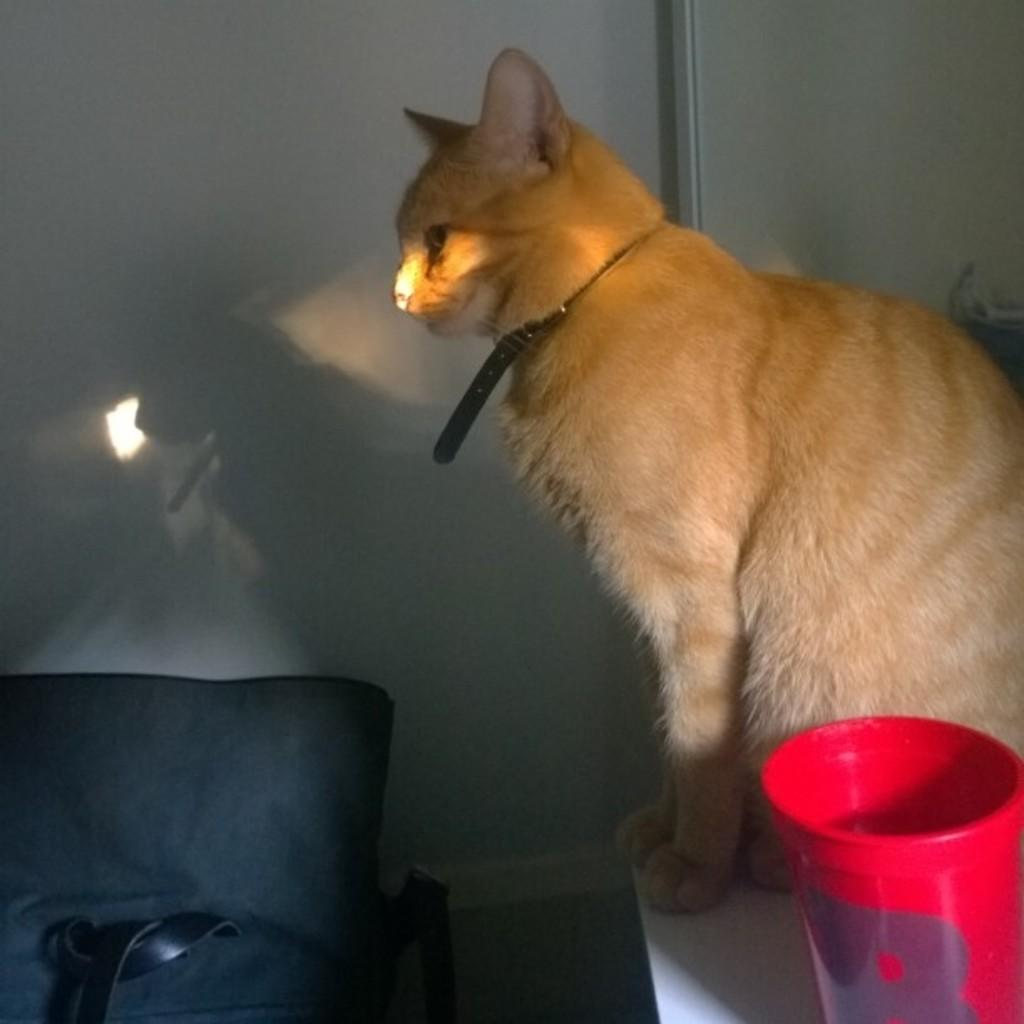What type of animal can be seen in the image? There is a cat in the image. What object is on the table in the image? There is a red color bucket on the table. What piece of furniture is on the left side of the image? There is a couch on the left side of the image. What can be seen in the background of the image? There is a wall in the background of the image. What type of cork is being used to hold the cat's tail in the image? There is no cork present in the image, nor is the cat's tail being held by any object. 